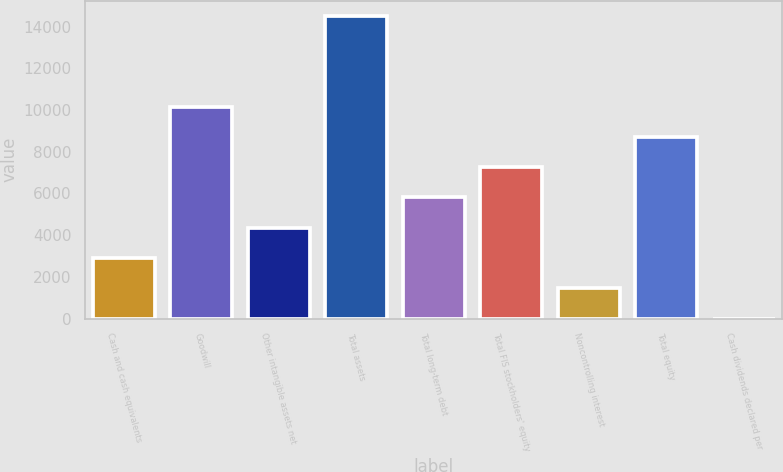Convert chart to OTSL. <chart><loc_0><loc_0><loc_500><loc_500><bar_chart><fcel>Cash and cash equivalents<fcel>Goodwill<fcel>Other intangible assets net<fcel>Total assets<fcel>Total long-term debt<fcel>Total FIS stockholders' equity<fcel>Noncontrolling interest<fcel>Total equity<fcel>Cash dividends declared per<nl><fcel>2904.96<fcel>10165<fcel>4356.96<fcel>14521<fcel>5808.96<fcel>7260.96<fcel>1452.96<fcel>8712.96<fcel>0.96<nl></chart> 